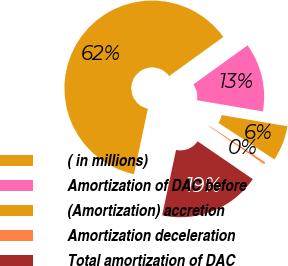<chart> <loc_0><loc_0><loc_500><loc_500><pie_chart><fcel>( in millions)<fcel>Amortization of DAC before<fcel>(Amortization) accretion<fcel>Amortization deceleration<fcel>Total amortization of DAC<nl><fcel>61.72%<fcel>12.64%<fcel>6.5%<fcel>0.37%<fcel>18.77%<nl></chart> 